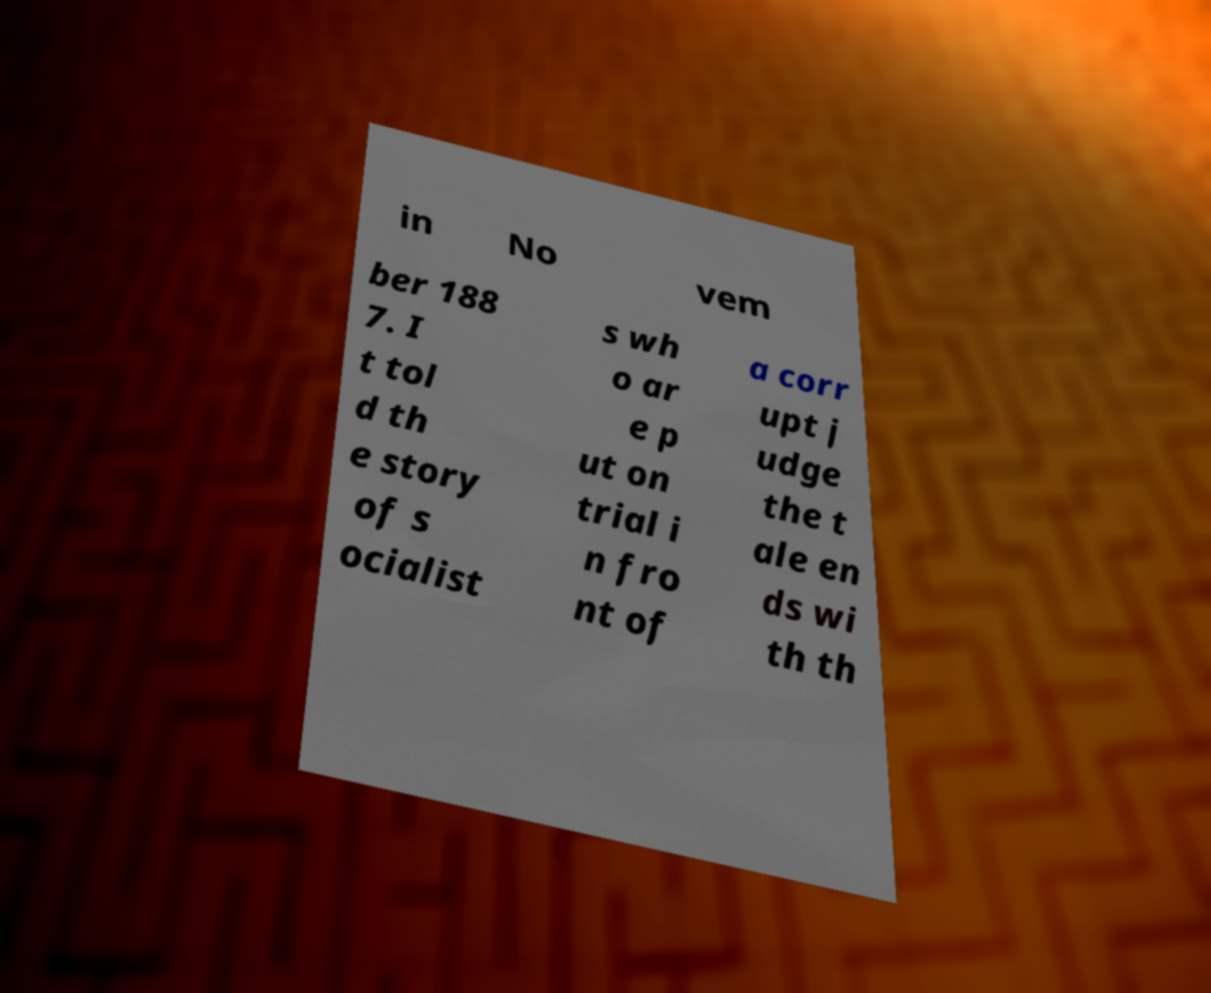Can you read and provide the text displayed in the image?This photo seems to have some interesting text. Can you extract and type it out for me? in No vem ber 188 7. I t tol d th e story of s ocialist s wh o ar e p ut on trial i n fro nt of a corr upt j udge the t ale en ds wi th th 